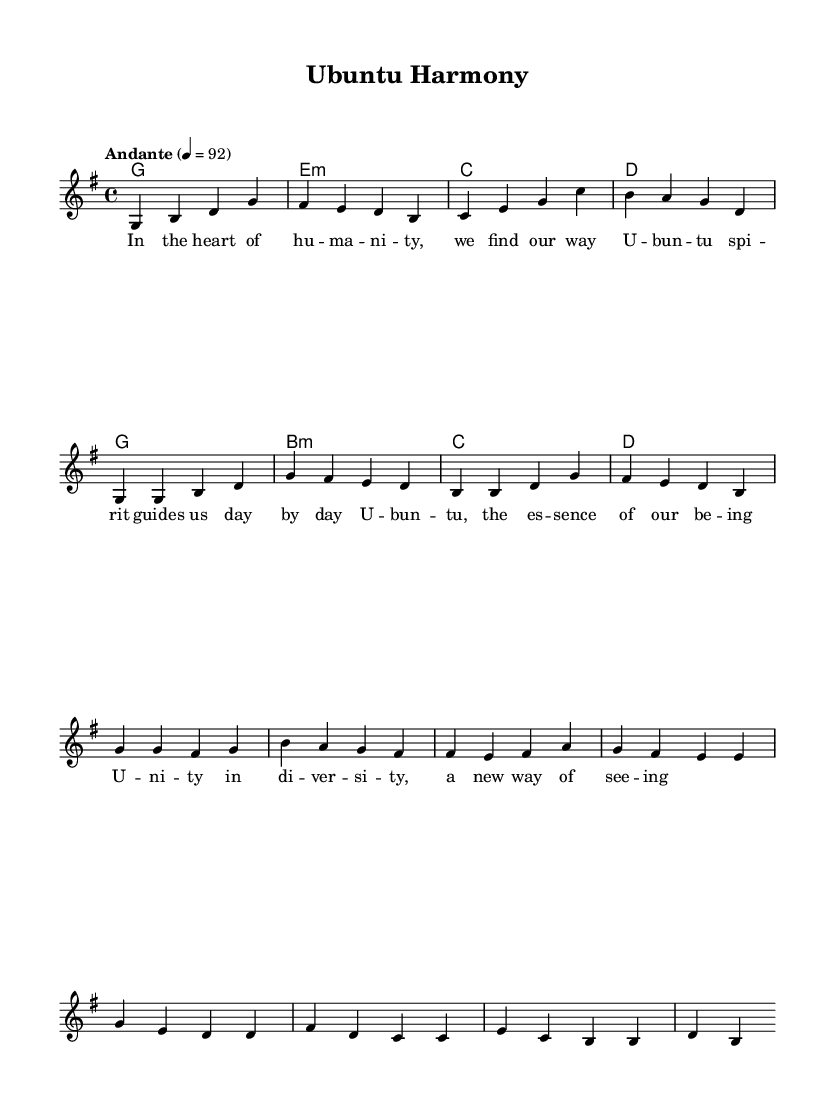What is the key signature of this music? The key signature is G major, which has one sharp (F#). This can be found in the first measure of the score, where the key is indicated by the 'g' in the global block.
Answer: G major What is the time signature of the piece? The time signature is 4/4, as shown in the global block where it specifies that each measure contains four beats. This is a common time signature in music, indicating a strong pulse.
Answer: 4/4 What is the tempo marking for the piece? The tempo is marked "Andante" with a metronome marking of 92. This is indicated in the global block, which describes the speed of the performance as moderately slow.
Answer: Andante, 92 How many measures are in the melody section provided? By counting the groups of four beats in the melody section from the first measure to the end of the provided music, there are a total of 10 measures. This total includes all intro, verse, chorus, and bridge sections.
Answer: 10 What do the words of the chorus convey? The chorus refers to 'Ubuntu', which represents unity and the essence of being. The specific phrases highlight the diversity while representing a harmonious spirit. In the context of the song, this showcases the spiritual connection central to the Ubuntu philosophy.
Answer: Unity in diversity What is the function of the harmonies in this piece? The harmonies support the melody by providing a foundation of chords that create emotional depth. Each chord has a specific role in harmonizing with the melody notes, enriching the overall sound, and following the structure of the song.
Answer: Support melody What is the relationship between the lyrics and the musical structure? The lyrics are structured to align with the musical form, where the verses set up the narrative, and the chorus provides a strong emotional statement. Each part contributes to the message of community and spirituality expressed through the Ubuntu philosophy.
Answer: Narrative alignment 